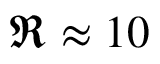<formula> <loc_0><loc_0><loc_500><loc_500>\Re \approx 1 0</formula> 